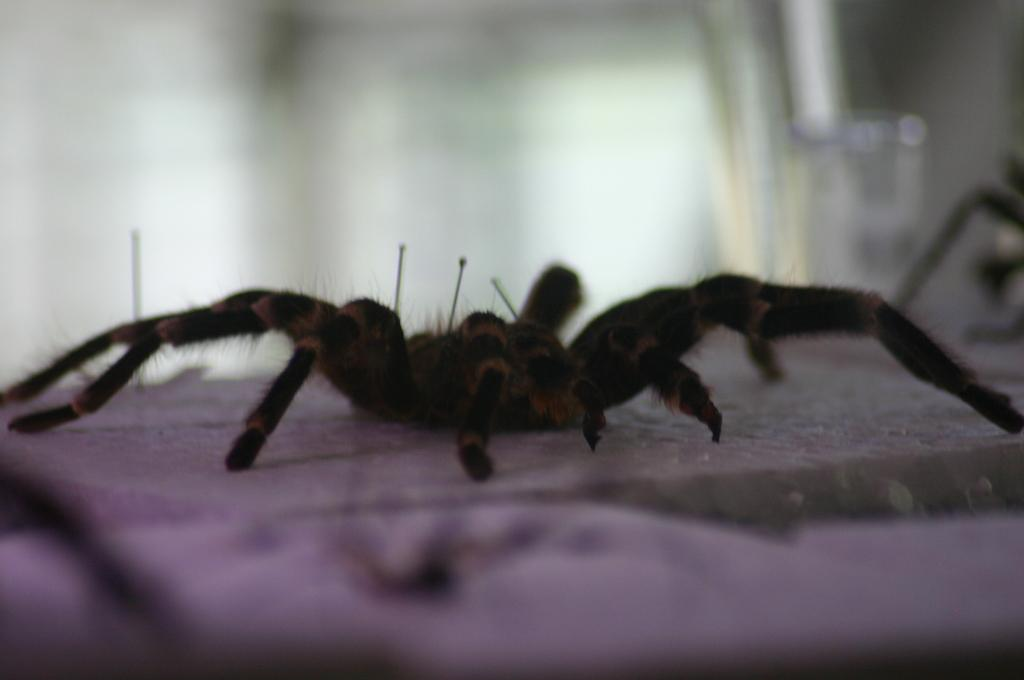What is present on the path in the image? There is a spider on the path in the image. Can you describe the background of the image? The background of the image is blurred. What type of pan can be seen in the image? There is no pan present in the image. How many boats are visible in the image? There are no boats visible in the image. 